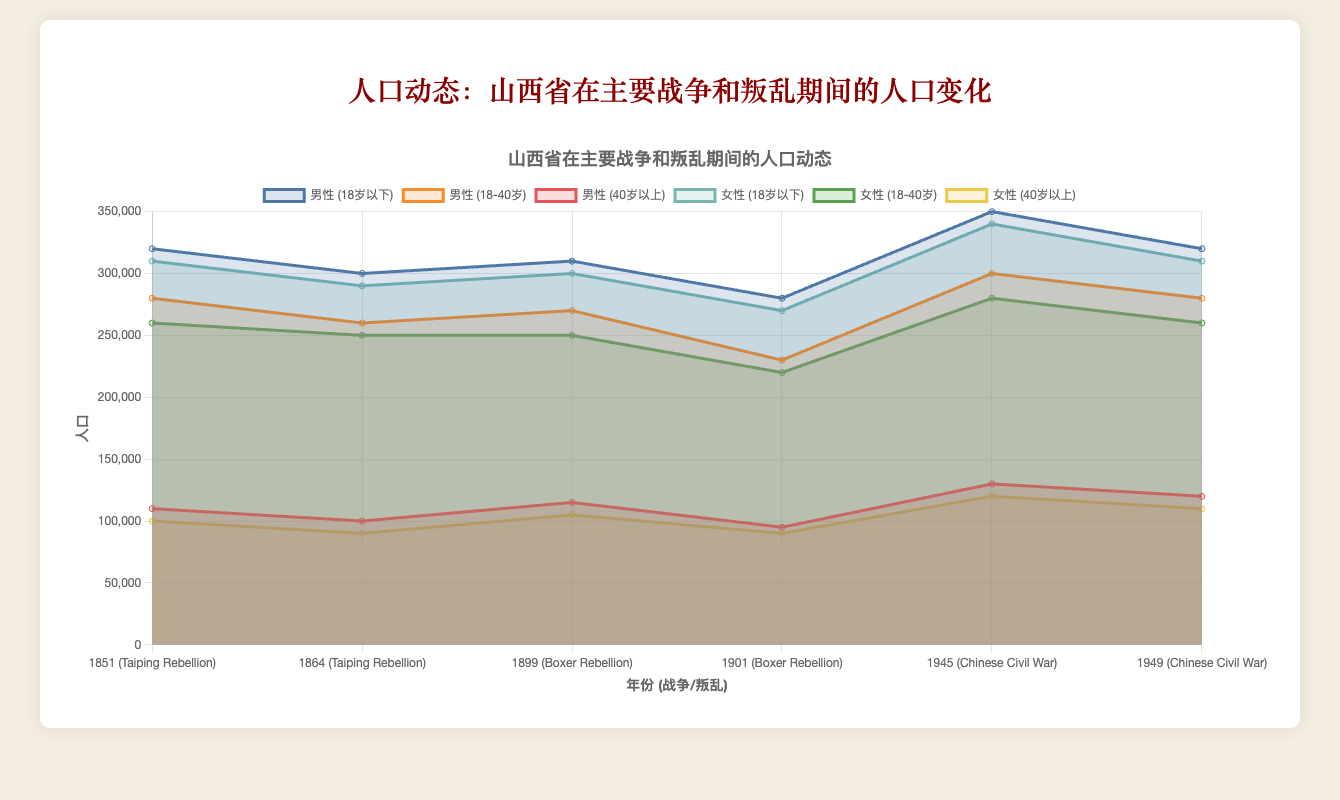What is the total population of males under 18 during the Taiping Rebellion in 1851? The area chart shows the population data for different age groups and genders during various wars. For males under 18 in 1851 (Taiping Rebellion), the population is represented on the chart. Simply refer to the relevant data point.
Answer: 320,000 How did the female population aged 18 to 40 change from 1899 to 1901 during the Boxer Rebellion? The female population aged 18 to 40 in 1899 was 250,000, and in 1901, it was 220,000. Subtracting these two values shows the decline. 250,000 - 220,000 = 30,000.
Answer: Decreased by 30,000 Which war period had the highest male population aged 40 and above? By looking at the peaks of the male population aged 40 and above on the chart, you can identify which year and corresponding war period had the highest population. The highest value is in 1945 during the Chinese Civil War with 130,000.
Answer: Chinese Civil War, 1945 What was the total population of Shanxi in 1945? To find the total population for all groups (male and female, all age groups) in 1945, sum each population segment. For males (350,000 + 300,000 + 130,000) and females (340,000 + 280,000 + 120,000). Add these sums together (780,000 + 740,000).
Answer: 1,520,000 By how much did the male population aged 18 to 40 decrease from the Taiping Rebellion in 1851 to 1864? The male population aged 18 to 40 in 1851 was 280,000, and in 1864, it declined to 260,000. Subtract these values (280,000 - 260,000) to find the decrease.
Answer: 20,000 What is the trend of the population of children (under 18) during the Taiping Rebellion? Observing the area chart across the years 1851 to 1864 during the Taiping Rebellion, the population of males under 18 decreases from 320,000 to 300,000, and for females from 310,000 to 290,000, indicating a downward trend.
Answer: Decreasing Which gender had a higher population in the 18 to 40 age group in 1899 during the Boxer Rebellion? Compare the chart data for males and females aged 18 to 40 in 1899 during the Boxer Rebellion. The population for males is 270,000, while for females it is 250,000.
Answer: Male What is the total female population under 18 across all recorded years? Sum the population of females under 18 across all the recorded years by adding each data point from the area chart: 310,000 (1851) + 290,000 (1864) + 300,000 (1899) + 270,000 (1901) + 340,000 (1945) + 310,000 (1949).
Answer: 1,820,000 How does the population change between the Chinese Civil War years in 1945 and 1949 for females aged 40 and above? The female population aged 40 and above in 1945 was 120,000, and in 1949, it was 110,000. Subtract the 1949 figure from the 1945 figure (120,000 - 110,000) to find the difference.
Answer: Decreased by 10,000 